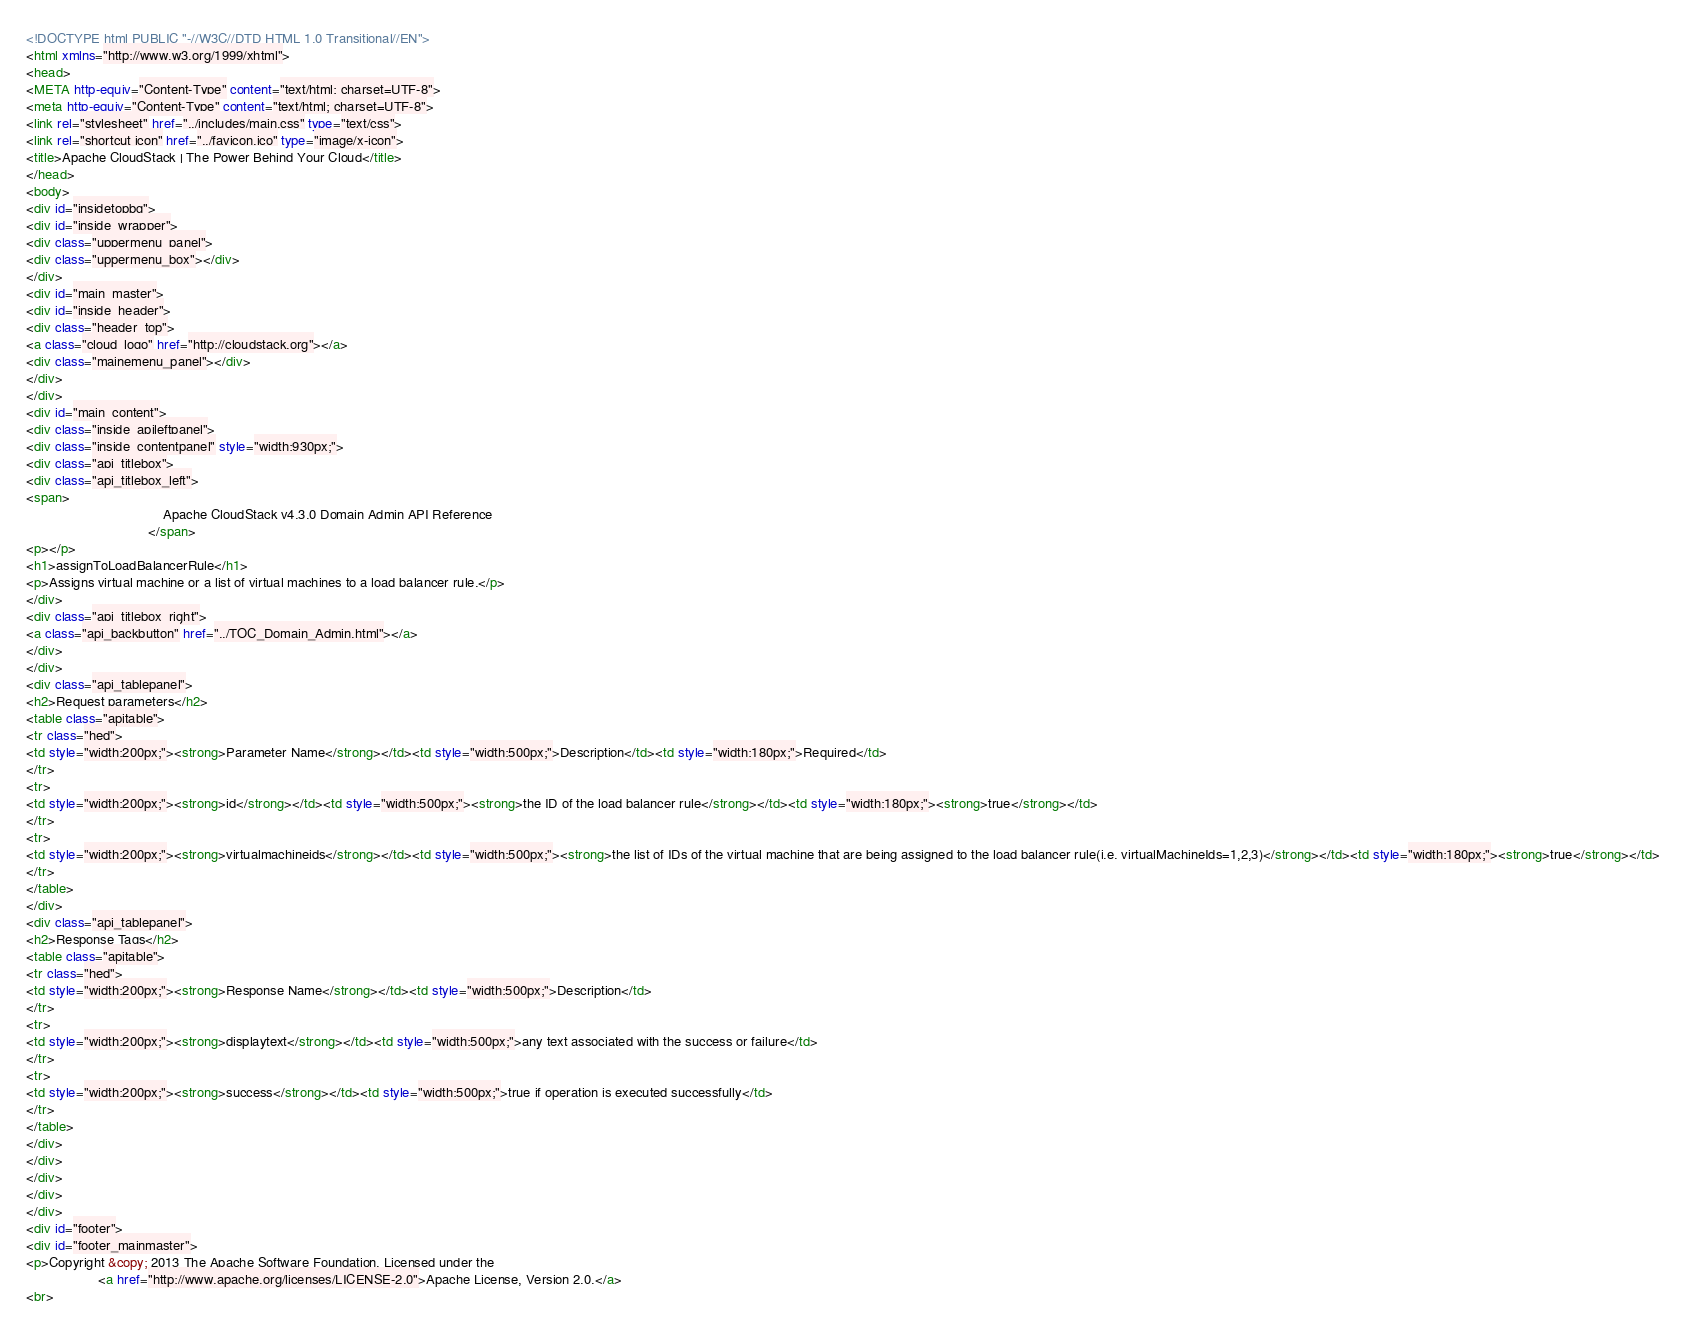<code> <loc_0><loc_0><loc_500><loc_500><_HTML_><!DOCTYPE html PUBLIC "-//W3C//DTD HTML 1.0 Transitional//EN">
<html xmlns="http://www.w3.org/1999/xhtml">
<head>
<META http-equiv="Content-Type" content="text/html; charset=UTF-8">
<meta http-equiv="Content-Type" content="text/html; charset=UTF-8">
<link rel="stylesheet" href="../includes/main.css" type="text/css">
<link rel="shortcut icon" href="../favicon.ico" type="image/x-icon">
<title>Apache CloudStack | The Power Behind Your Cloud</title>
</head>
<body>
<div id="insidetopbg">
<div id="inside_wrapper">
<div class="uppermenu_panel">
<div class="uppermenu_box"></div>
</div>
<div id="main_master">
<div id="inside_header">
<div class="header_top">
<a class="cloud_logo" href="http://cloudstack.org"></a>
<div class="mainemenu_panel"></div>
</div>
</div>
<div id="main_content">
<div class="inside_apileftpanel">
<div class="inside_contentpanel" style="width:930px;">
<div class="api_titlebox">
<div class="api_titlebox_left">
<span>
									Apache CloudStack v4.3.0 Domain Admin API Reference
								</span>
<p></p>
<h1>assignToLoadBalancerRule</h1>
<p>Assigns virtual machine or a list of virtual machines to a load balancer rule.</p>
</div>
<div class="api_titlebox_right">
<a class="api_backbutton" href="../TOC_Domain_Admin.html"></a>
</div>
</div>
<div class="api_tablepanel">
<h2>Request parameters</h2>
<table class="apitable">
<tr class="hed">
<td style="width:200px;"><strong>Parameter Name</strong></td><td style="width:500px;">Description</td><td style="width:180px;">Required</td>
</tr>
<tr>
<td style="width:200px;"><strong>id</strong></td><td style="width:500px;"><strong>the ID of the load balancer rule</strong></td><td style="width:180px;"><strong>true</strong></td>
</tr>
<tr>
<td style="width:200px;"><strong>virtualmachineids</strong></td><td style="width:500px;"><strong>the list of IDs of the virtual machine that are being assigned to the load balancer rule(i.e. virtualMachineIds=1,2,3)</strong></td><td style="width:180px;"><strong>true</strong></td>
</tr>
</table>
</div>
<div class="api_tablepanel">
<h2>Response Tags</h2>
<table class="apitable">
<tr class="hed">
<td style="width:200px;"><strong>Response Name</strong></td><td style="width:500px;">Description</td>
</tr>
<tr>
<td style="width:200px;"><strong>displaytext</strong></td><td style="width:500px;">any text associated with the success or failure</td>
</tr>
<tr>
<td style="width:200px;"><strong>success</strong></td><td style="width:500px;">true if operation is executed successfully</td>
</tr>
</table>
</div>
</div>
</div>
</div>
</div>
<div id="footer">
<div id="footer_mainmaster">
<p>Copyright &copy; 2013 The Apache Software Foundation, Licensed under the
                   <a href="http://www.apache.org/licenses/LICENSE-2.0">Apache License, Version 2.0.</a>
<br></code> 